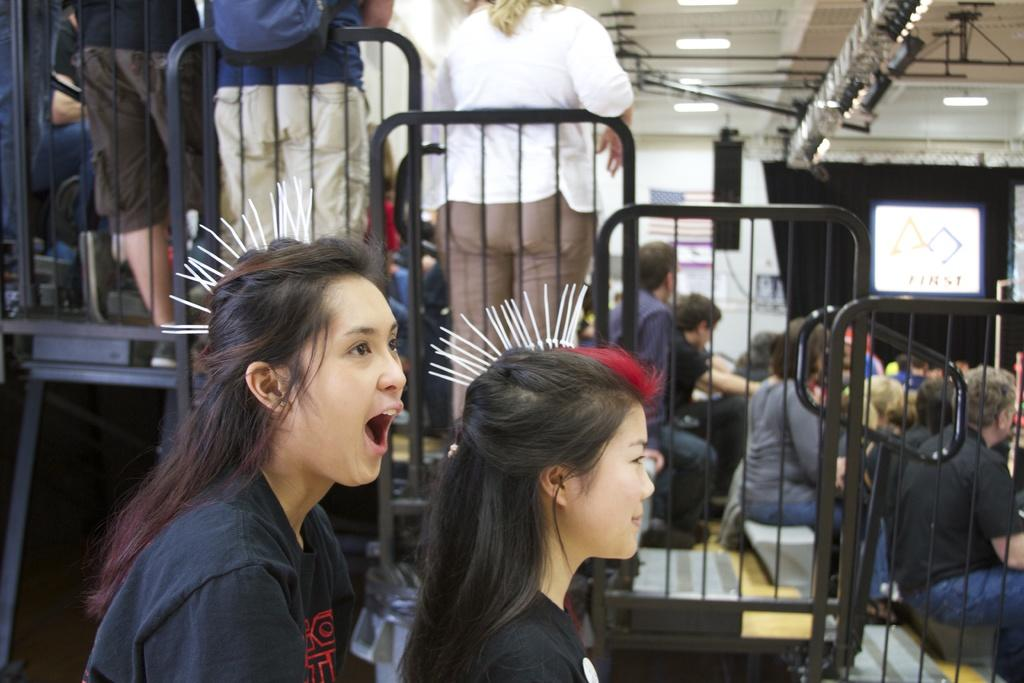What type of structure can be seen in the image? There is a fencing in the image. Can you describe the people in the image? There are people in the image. What is the purpose of the display in the image? The purpose of the display is not clear from the facts provided. What can be seen illuminated in the image? There are lights in the image. What type of building is visible at the top of the image? There is a shed visible at the top of the image. Can you describe the thrill of the grass in the image? There is no grass present in the image, so it is not possible to describe the thrill of the grass. 